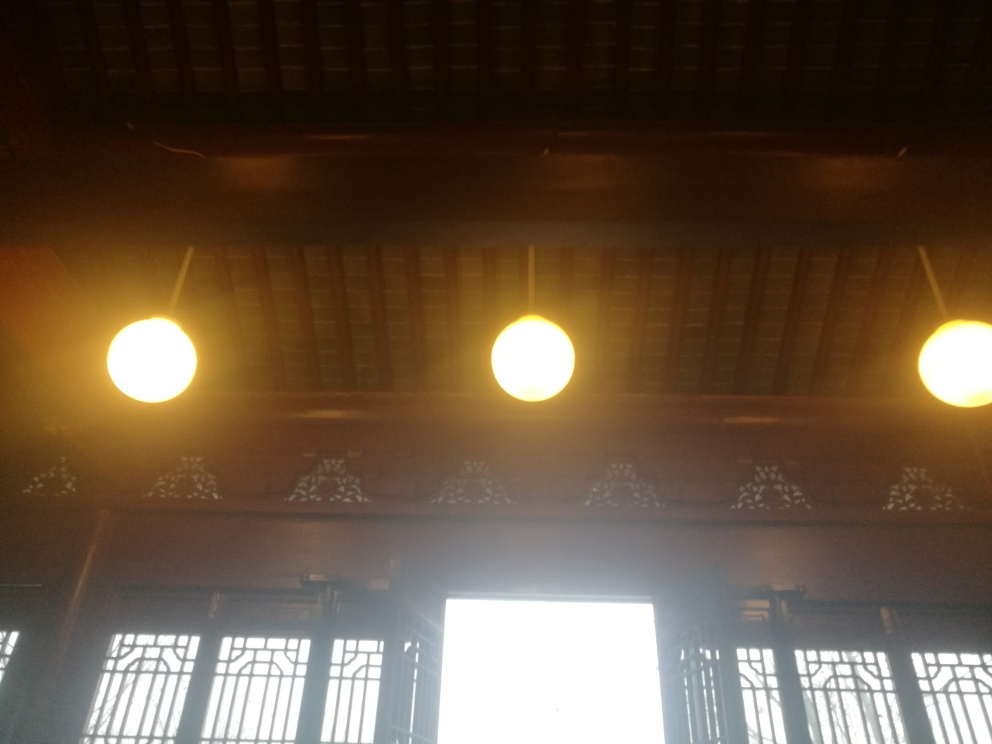How could the composition of this image be improved? To improve the composition, the photographer could apply the rule of thirds by repositioning the light sources to the intersecting points, which would create a more balanced and aesthetically pleasing image. Additionally, adjusting the angle to avoid direct view of the bright window could enrich the composition with more interior details. 